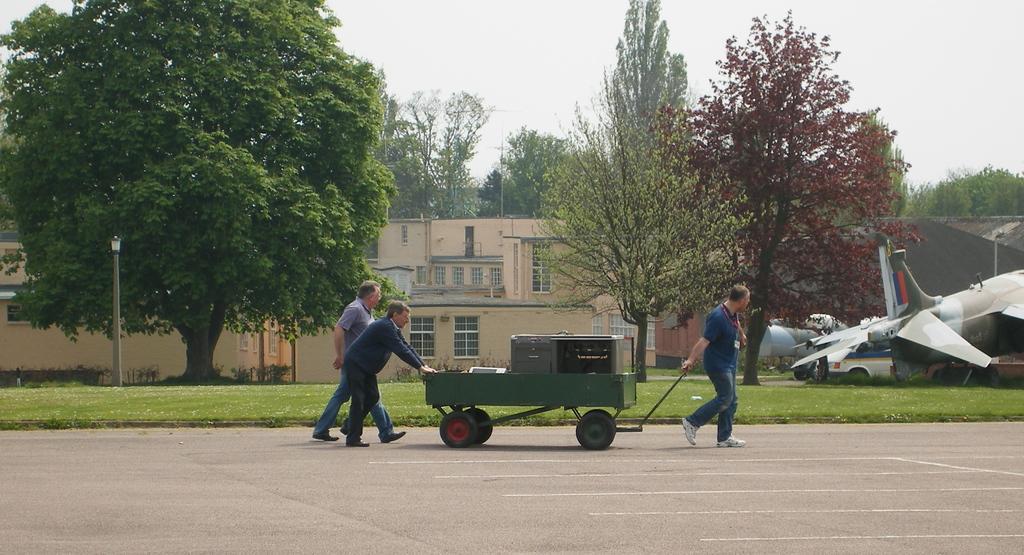Could you give a brief overview of what you see in this image? In the middle of the image few people are walking and holding a vehicle. Behind them there is grass and there are some trees and buildings and poles. At the top of the image there is sky. On the right side of the image there is a plane. Behind the plane there is a vehicle. 